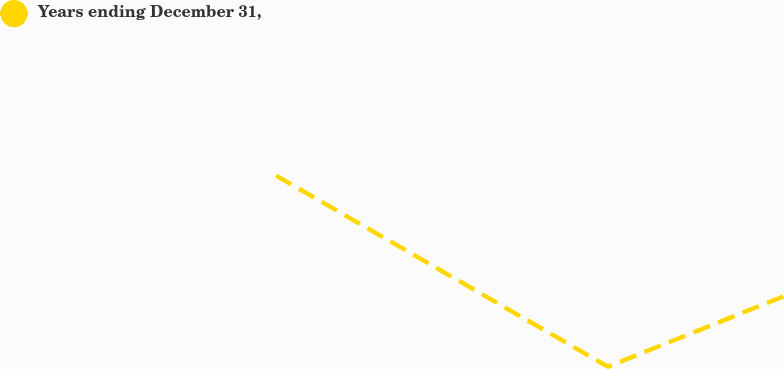Convert chart to OTSL. <chart><loc_0><loc_0><loc_500><loc_500><line_chart><ecel><fcel>Years ending December 31,<nl><fcel>1789<fcel>37269<nl><fcel>1920.26<fcel>29303.9<nl><fcel>1990.73<fcel>32276.8<nl><fcel>2245.14<fcel>27526.1<nl><fcel>2295.21<fcel>30278.2<nl></chart> 